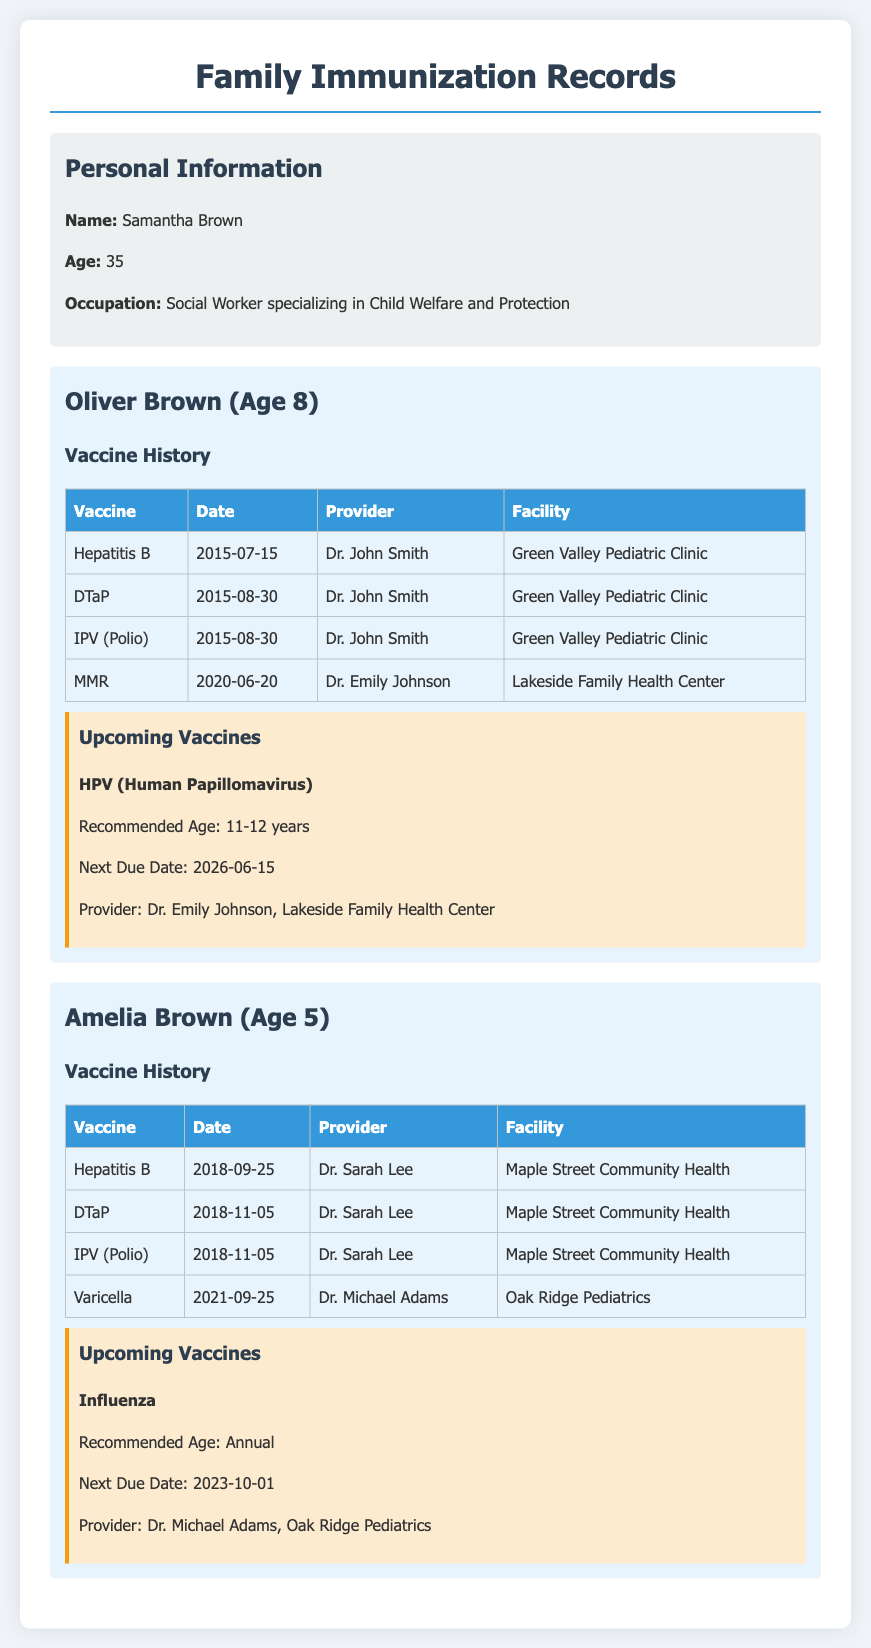What is the name of the mother? The document provides the personal information of Samantha Brown as the mother.
Answer: Samantha Brown How old is Oliver Brown? Oliver's age is mentioned under his name in the document.
Answer: 8 What vaccine was administered to Amelia Brown on 2021-09-25? The document lists the vaccines administered to Amelia, including Varicella.
Answer: Varicella Who is the provider for Oliver's HPV vaccine? The provider's name for Oliver's upcoming HPV vaccine is mentioned in the document.
Answer: Dr. Emily Johnson What is the next due date for Amelia's influenza vaccine? The document states the next due date for the influenza vaccine.
Answer: 2023-10-01 How many vaccines has Oliver received as of the document creation? By counting the vaccines listed under Oliver's vaccine history, the total can be determined.
Answer: 4 What facility provided the DTaP to Amelia? The document specifies the facility where Amelia received the DTaP vaccine.
Answer: Maple Street Community Health At what age is the HPV vaccine recommended for Oliver? This information is provided in the upcoming vaccines section for Oliver.
Answer: 11-12 years Which vaccine is scheduled for Amelia's upcoming appointment? The document clearly lists Amelia's upcoming influenza vaccine.
Answer: Influenza 